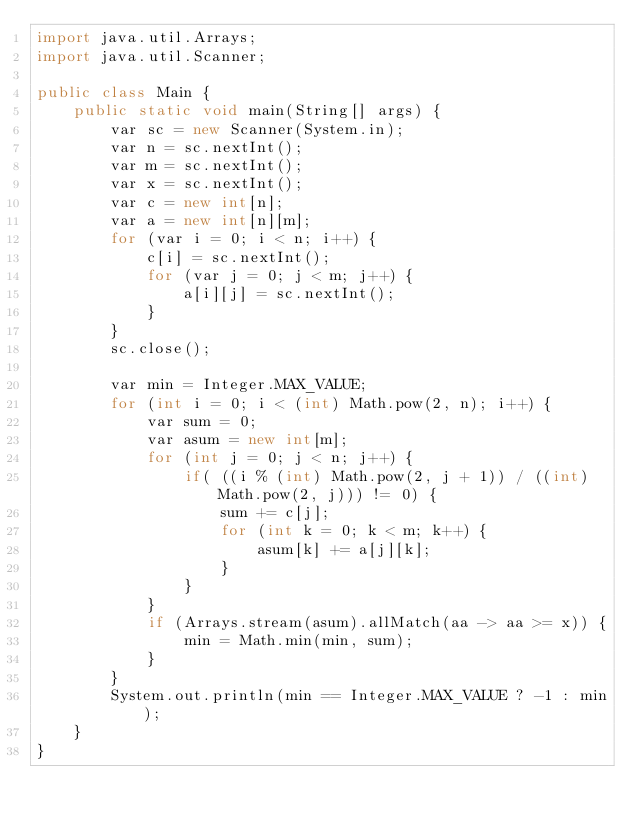Convert code to text. <code><loc_0><loc_0><loc_500><loc_500><_Java_>import java.util.Arrays;
import java.util.Scanner;

public class Main {
	public static void main(String[] args) {
		var sc = new Scanner(System.in);
		var n = sc.nextInt();
		var m = sc.nextInt();
		var x = sc.nextInt();
		var c = new int[n];
		var a = new int[n][m];
		for (var i = 0; i < n; i++) {
			c[i] = sc.nextInt();
			for (var j = 0; j < m; j++) {
				a[i][j] = sc.nextInt();
			}
		}
		sc.close();

		var min = Integer.MAX_VALUE;
		for (int i = 0; i < (int) Math.pow(2, n); i++) {
			var sum = 0;
			var asum = new int[m];
			for (int j = 0; j < n; j++) {
				if( ((i % (int) Math.pow(2, j + 1)) / ((int) Math.pow(2, j))) != 0) {
					sum += c[j];
					for (int k = 0; k < m; k++) {
						asum[k] += a[j][k];
					}
				}
			}
			if (Arrays.stream(asum).allMatch(aa -> aa >= x)) {
				min = Math.min(min, sum);
			}
		}
		System.out.println(min == Integer.MAX_VALUE ? -1 : min);
	}
}</code> 